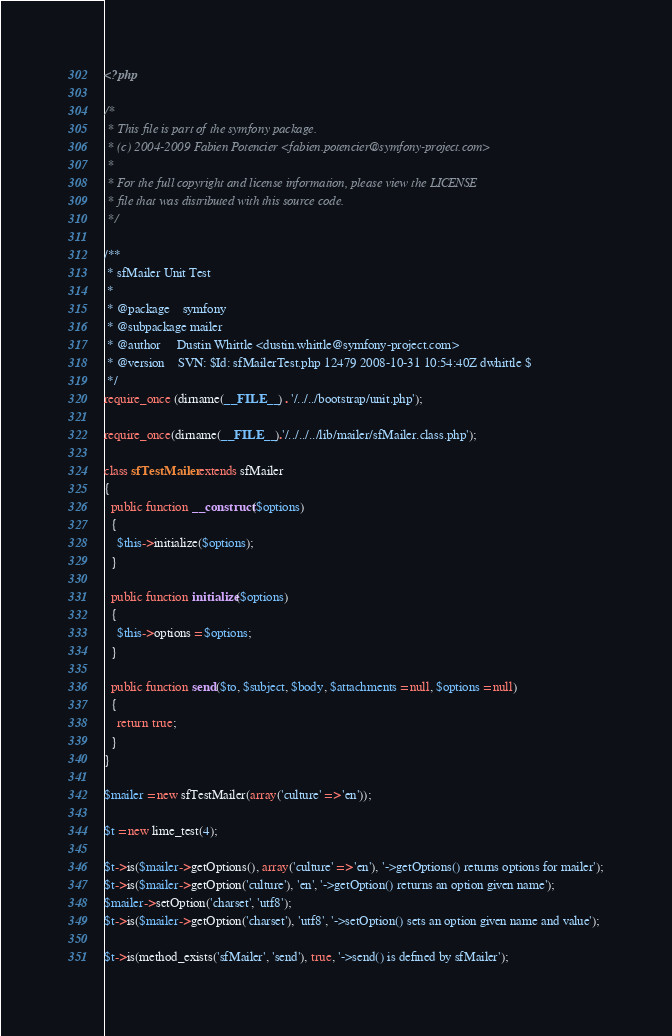Convert code to text. <code><loc_0><loc_0><loc_500><loc_500><_PHP_><?php

/*
 * This file is part of the symfony package.
 * (c) 2004-2009 Fabien Potencier <fabien.potencier@symfony-project.com>
 *
 * For the full copyright and license information, please view the LICENSE
 * file that was distributed with this source code.
 */

/**
 * sfMailer Unit Test
 *
 * @package    symfony
 * @subpackage mailer
 * @author     Dustin Whittle <dustin.whittle@symfony-project.com>
 * @version    SVN: $Id: sfMailerTest.php 12479 2008-10-31 10:54:40Z dwhittle $
 */
require_once (dirname(__FILE__) . '/../../bootstrap/unit.php');

require_once(dirname(__FILE__).'/../../../lib/mailer/sfMailer.class.php'); 

class sfTestMailer extends sfMailer
{
  public function __construct($options)
  {
    $this->initialize($options);
  }
  
  public function initialize($options)
  {
    $this->options = $options;    
  }
  
  public function send($to, $subject, $body, $attachments = null, $options = null)
  {
    return true;
  }
}

$mailer = new sfTestMailer(array('culture' => 'en'));

$t = new lime_test(4);

$t->is($mailer->getOptions(), array('culture' => 'en'), '->getOptions() returns options for mailer');
$t->is($mailer->getOption('culture'), 'en', '->getOption() returns an option given name');
$mailer->setOption('charset', 'utf8');
$t->is($mailer->getOption('charset'), 'utf8', '->setOption() sets an option given name and value');

$t->is(method_exists('sfMailer', 'send'), true, '->send() is defined by sfMailer');
</code> 